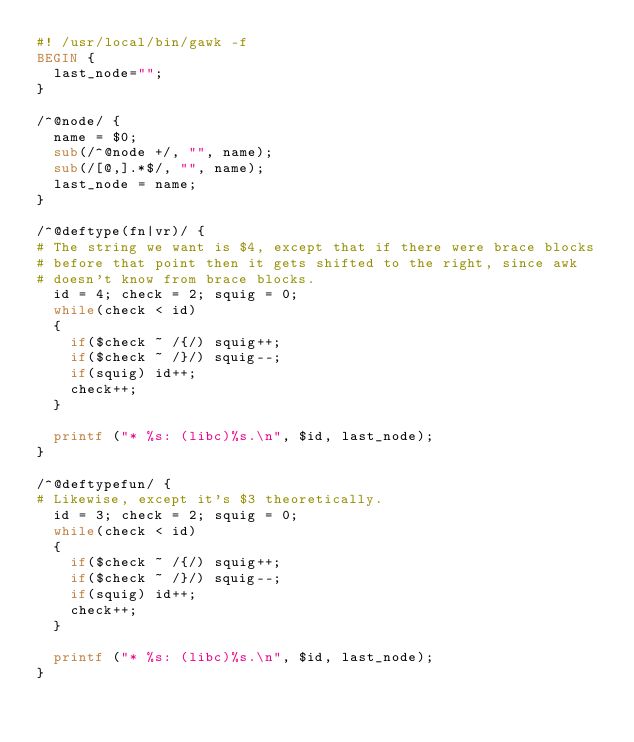Convert code to text. <code><loc_0><loc_0><loc_500><loc_500><_Awk_>#! /usr/local/bin/gawk -f
BEGIN {
  last_node="";
}

/^@node/ {
  name = $0;
  sub(/^@node +/, "", name);
  sub(/[@,].*$/, "", name);
  last_node = name;
}

/^@deftype(fn|vr)/ {
# The string we want is $4, except that if there were brace blocks
# before that point then it gets shifted to the right, since awk
# doesn't know from brace blocks.
  id = 4; check = 2; squig = 0;
  while(check < id)
  {
    if($check ~ /{/) squig++;
    if($check ~ /}/) squig--;
    if(squig) id++;
    check++;
  }

  printf ("* %s: (libc)%s.\n", $id, last_node);
}

/^@deftypefun/ {
# Likewise, except it's $3 theoretically.
  id = 3; check = 2; squig = 0;
  while(check < id)
  {
    if($check ~ /{/) squig++;
    if($check ~ /}/) squig--;
    if(squig) id++;
    check++;
  }

  printf ("* %s: (libc)%s.\n", $id, last_node);
}
</code> 